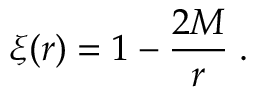<formula> <loc_0><loc_0><loc_500><loc_500>\xi ( r ) = 1 - \frac { 2 M } { r } \, .</formula> 